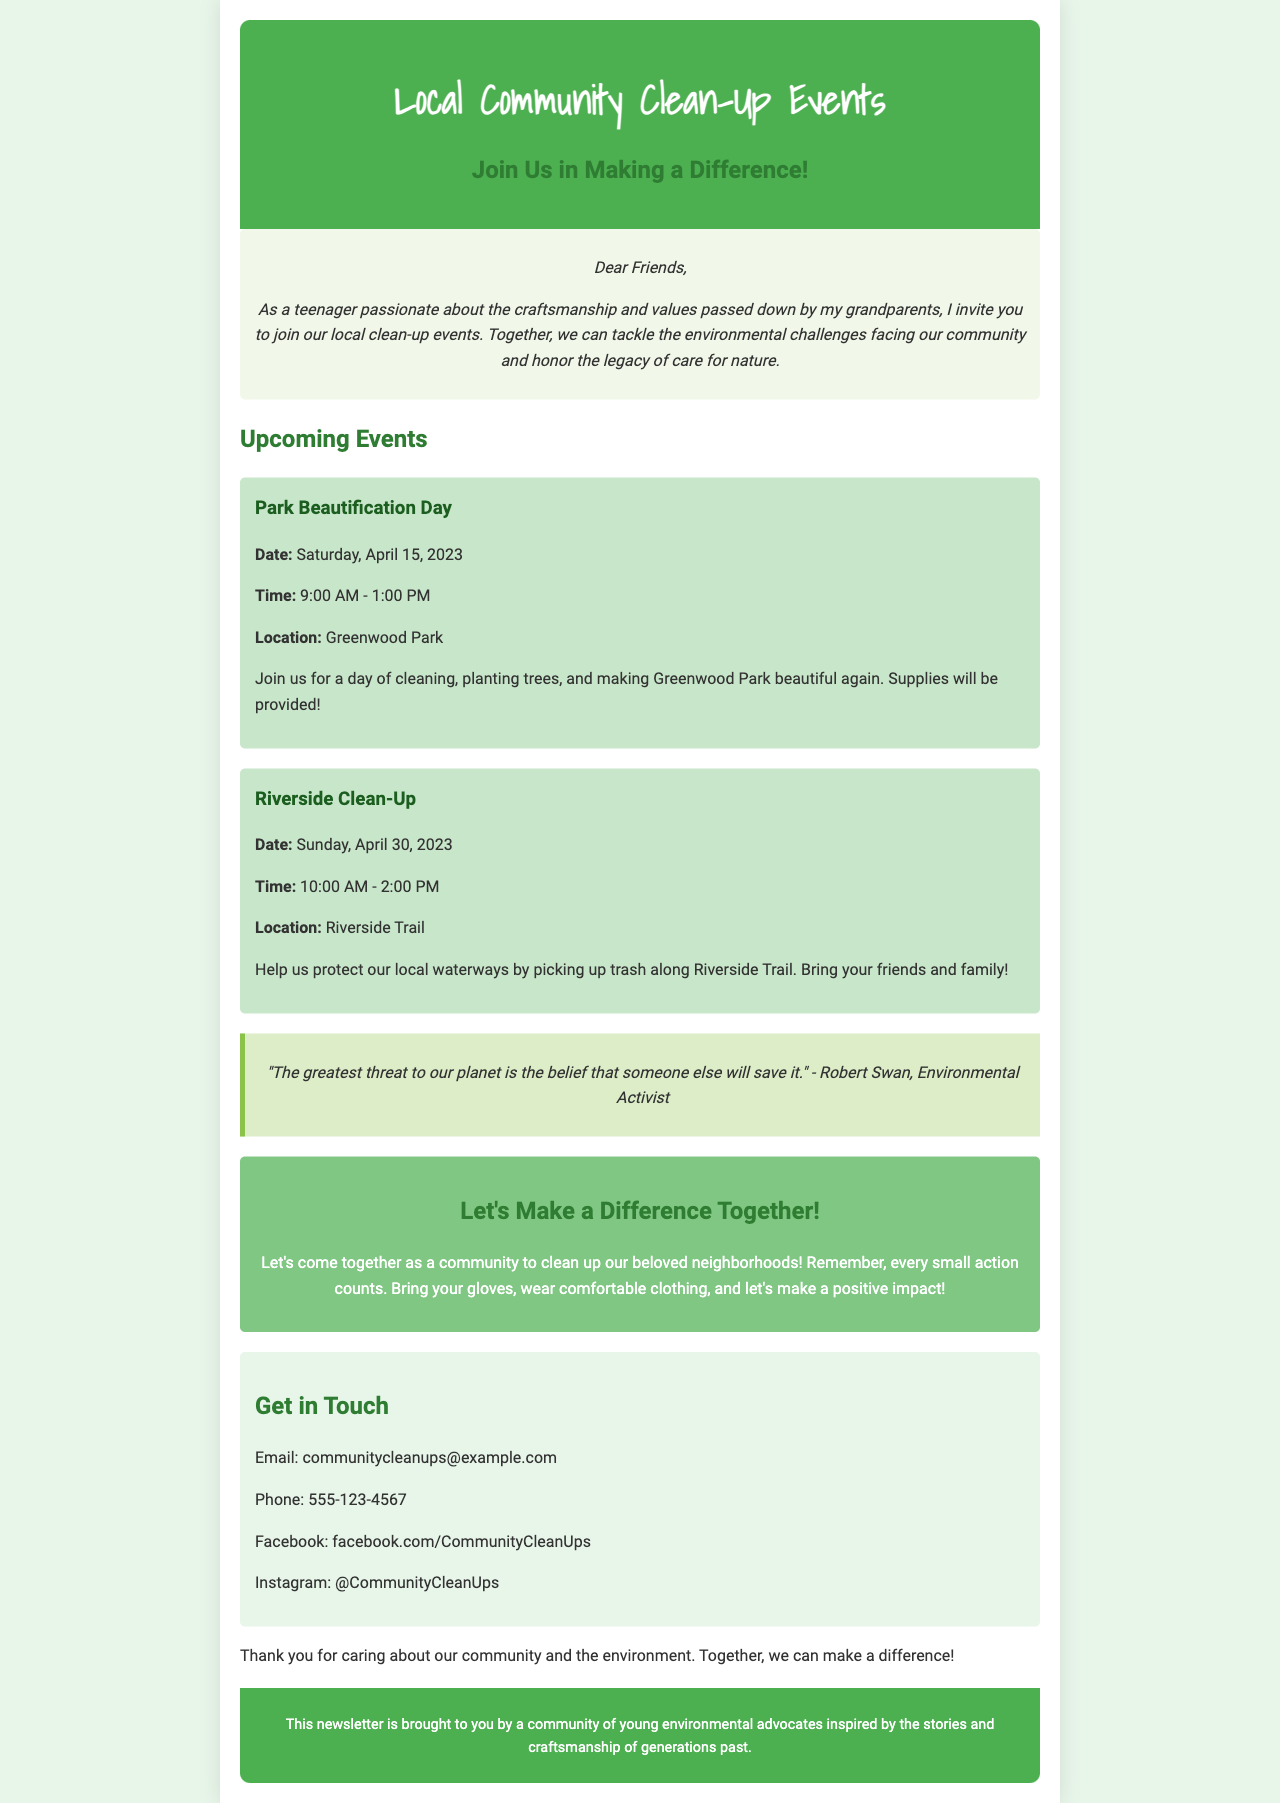What is the title of the newsletter? The title of the newsletter is presented prominently at the top of the document, indicating the main topic of the content.
Answer: Local Community Clean-Up Events When is the Park Beautification Day event scheduled? The date of the Park Beautification Day is specified under the upcoming events section in the document.
Answer: Saturday, April 15, 2023 What time does the Riverside Clean-Up start? The start time for the Riverside Clean-Up can be found within the details of that particular event in the newsletter.
Answer: 10:00 AM Where will the Park Beautification Day take place? The location for the Park Beautification Day is listed in the event details section of the newsletter.
Answer: Greenwood Park What is the main purpose of the clean-up events? The purpose of these events is outlined in the introduction and is focused on improving the local community environment.
Answer: Making a difference Who is the quote in the newsletter attributed to? The quote is included in the document with the name of the person who made the statement regarding environmental issues.
Answer: Robert Swan What should participants bring to the clean-up events? The details about what participants should prepare or bring are highlighted in the call-to-action section of the newsletter.
Answer: Gloves How can people get in touch for more information? Contact details are provided in the newsletter for those wishing to reach out for more information regarding the events.
Answer: communitycleanups@example.com Which environmental issue is being addressed by the clean-up events? The overarching theme of the newsletter indicates a focus on environmental challenges facing the community.
Answer: Environmental challenges 